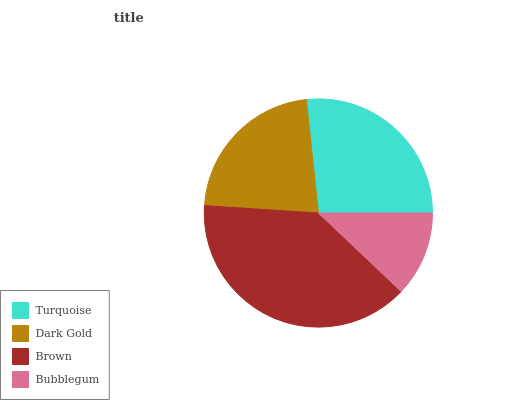Is Bubblegum the minimum?
Answer yes or no. Yes. Is Brown the maximum?
Answer yes or no. Yes. Is Dark Gold the minimum?
Answer yes or no. No. Is Dark Gold the maximum?
Answer yes or no. No. Is Turquoise greater than Dark Gold?
Answer yes or no. Yes. Is Dark Gold less than Turquoise?
Answer yes or no. Yes. Is Dark Gold greater than Turquoise?
Answer yes or no. No. Is Turquoise less than Dark Gold?
Answer yes or no. No. Is Turquoise the high median?
Answer yes or no. Yes. Is Dark Gold the low median?
Answer yes or no. Yes. Is Brown the high median?
Answer yes or no. No. Is Brown the low median?
Answer yes or no. No. 